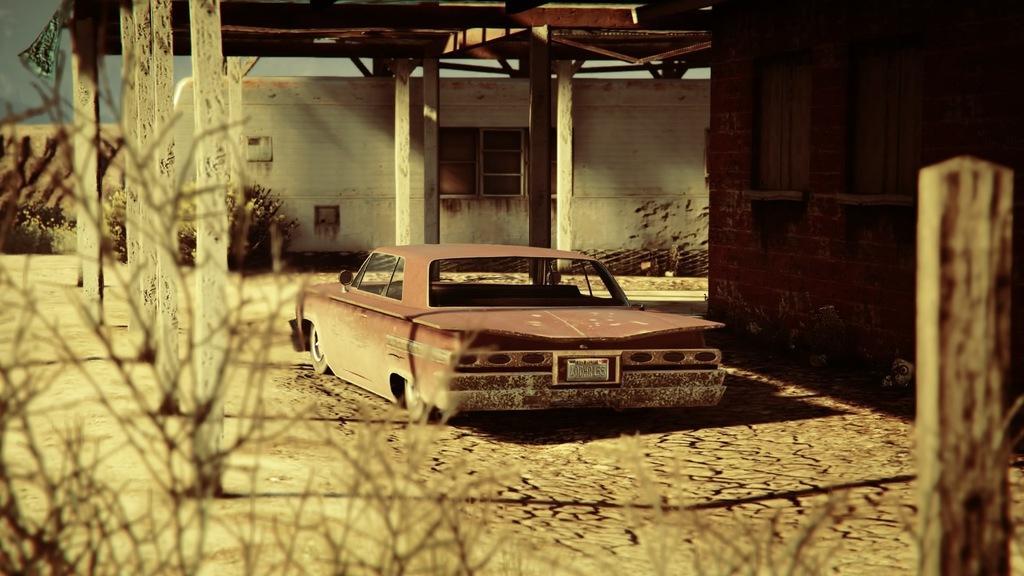Can you describe this image briefly? In this image we can see a car under a wooden roof. We can also see some wooden poles, plants, wall, branches of a tree and the sky. 